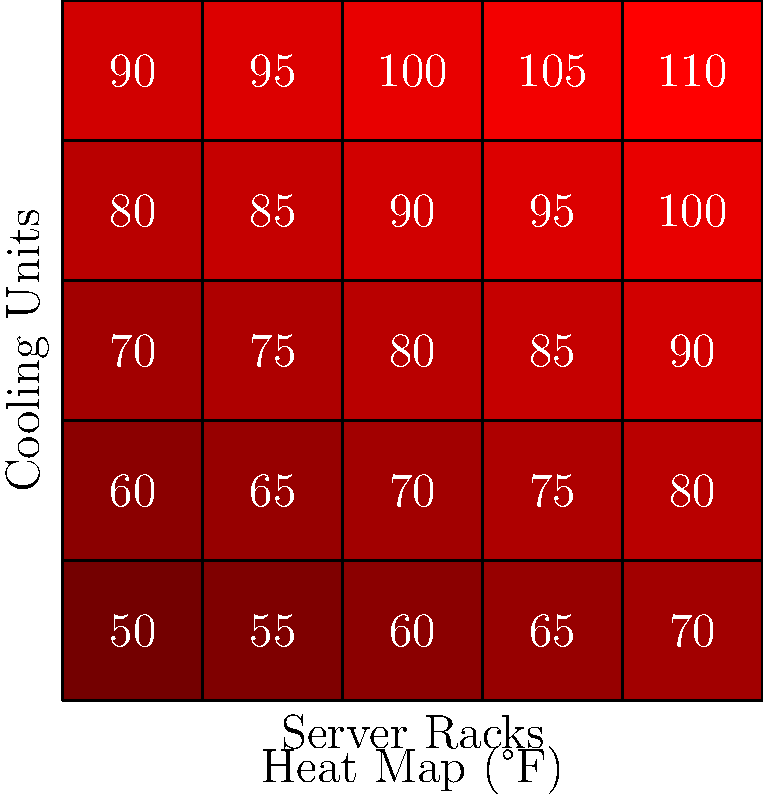Based on the heat map diagram of a data center, which area requires immediate attention to improve energy efficiency, and what strategy would you recommend to address this issue? To answer this question, let's analyze the heat map step-by-step:

1. The heat map shows temperatures in a data center, with darker red indicating higher temperatures.
2. The x-axis represents server racks, while the y-axis represents cooling units.
3. Temperatures range from 50°F to 110°F across the data center.
4. The hottest area is in the top-right corner, with a temperature of 110°F.
5. This area requires immediate attention as it indicates poor cooling efficiency and potential equipment stress.

To address this issue:

1. Identify the cause: The high temperature in the top-right corner suggests that cooling is inadequate in this area.
2. Implement hot/cold aisle containment: Separate hot and cold air to improve cooling efficiency.
3. Optimize airflow: Ensure proper ventilation and remove any obstructions.
4. Upgrade cooling systems: Consider adding more cooling capacity or implementing liquid cooling for high-density racks.
5. Use intelligent cooling management: Implement sensors and AI-driven cooling systems to dynamically adjust cooling based on real-time heat generation.

The most effective strategy would be to implement a combination of hot/cold aisle containment and intelligent cooling management. This approach addresses the immediate issue while providing a long-term solution for energy efficiency.
Answer: Implement hot/cold aisle containment and intelligent cooling management in the top-right corner (110°F area). 